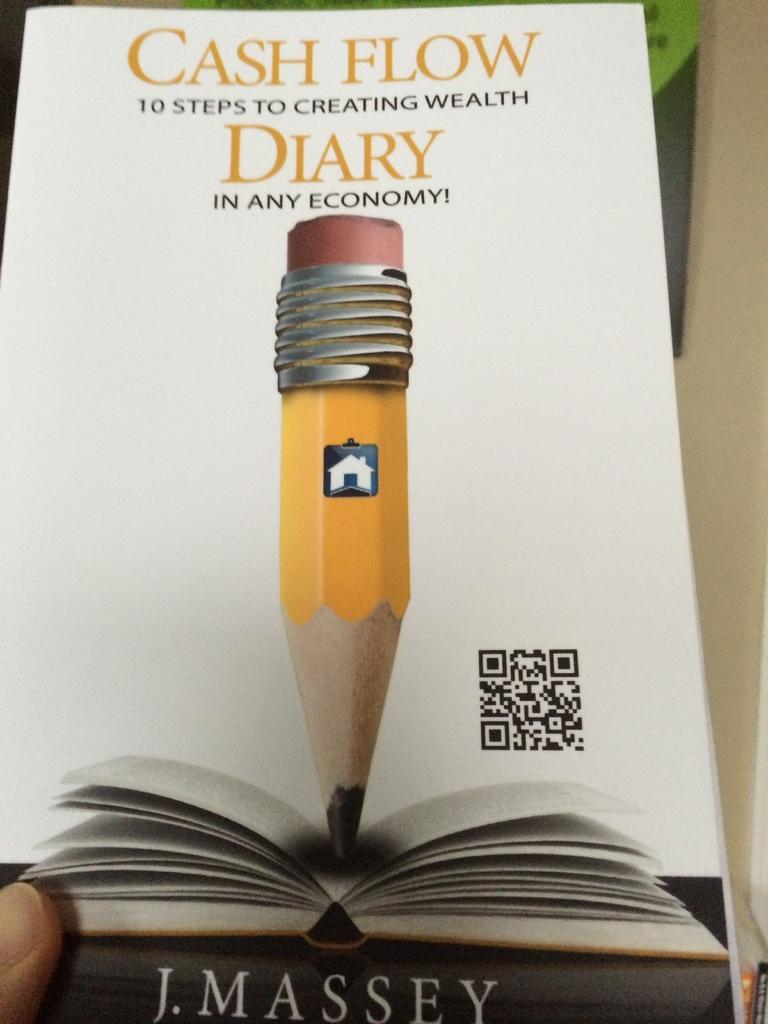Is this by j. massey?
Your answer should be very brief. Yes. What is the first line of the title?
Ensure brevity in your answer.  Cash flow. 